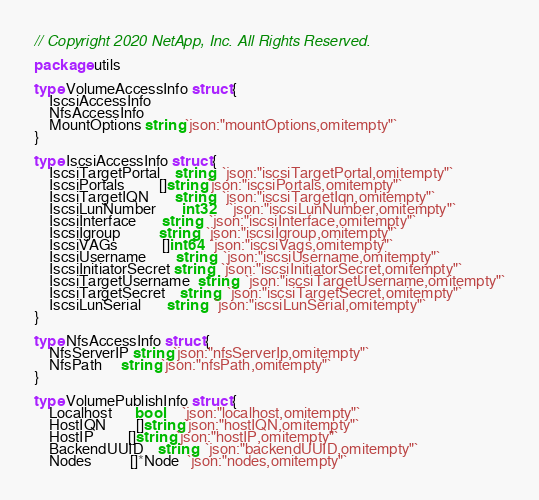<code> <loc_0><loc_0><loc_500><loc_500><_Go_>// Copyright 2020 NetApp, Inc. All Rights Reserved.

package utils

type VolumeAccessInfo struct {
	IscsiAccessInfo
	NfsAccessInfo
	MountOptions string `json:"mountOptions,omitempty"`
}

type IscsiAccessInfo struct {
	IscsiTargetPortal    string   `json:"iscsiTargetPortal,omitempty"`
	IscsiPortals         []string `json:"iscsiPortals,omitempty"`
	IscsiTargetIQN       string   `json:"iscsiTargetIqn,omitempty"`
	IscsiLunNumber       int32    `json:"iscsiLunNumber,omitempty"`
	IscsiInterface       string   `json:"iscsiInterface,omitempty"`
	IscsiIgroup          string   `json:"iscsiIgroup,omitempty"`
	IscsiVAGs            []int64  `json:"iscsiVags,omitempty"`
	IscsiUsername        string   `json:"iscsiUsername,omitempty"`
	IscsiInitiatorSecret string   `json:"iscsiInitiatorSecret,omitempty"`
	IscsiTargetUsername  string   `json:"iscsiTargetUsername,omitempty"`
	IscsiTargetSecret    string   `json:"iscsiTargetSecret,omitempty"`
	IscsiLunSerial       string   `json:"iscsiLunSerial,omitempty"`
}

type NfsAccessInfo struct {
	NfsServerIP string `json:"nfsServerIp,omitempty"`
	NfsPath     string `json:"nfsPath,omitempty"`
}

type VolumePublishInfo struct {
	Localhost      bool     `json:"localhost,omitempty"`
	HostIQN        []string `json:"hostIQN,omitempty"`
	HostIP         []string `json:"hostIP,omitempty"`
	BackendUUID    string   `json:"backendUUID,omitempty"`
	Nodes          []*Node  `json:"nodes,omitempty"`</code> 